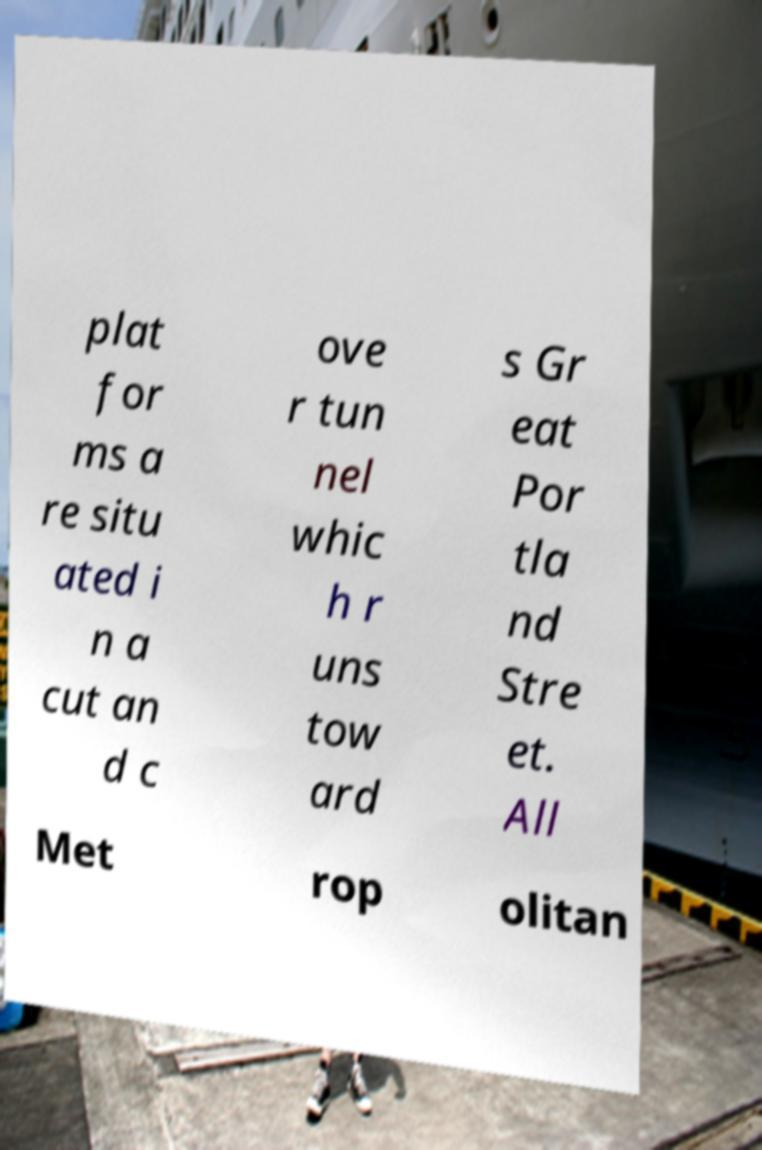For documentation purposes, I need the text within this image transcribed. Could you provide that? plat for ms a re situ ated i n a cut an d c ove r tun nel whic h r uns tow ard s Gr eat Por tla nd Stre et. All Met rop olitan 